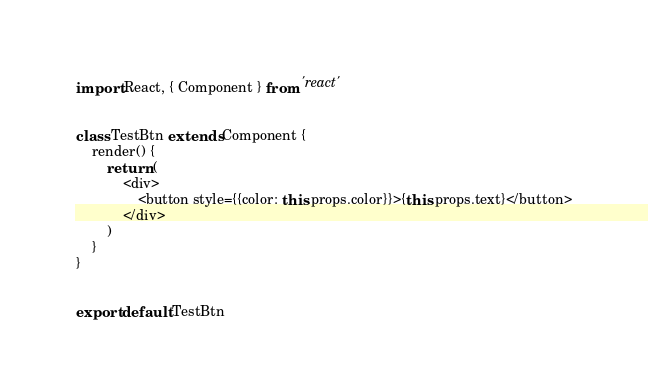<code> <loc_0><loc_0><loc_500><loc_500><_JavaScript_>import React, { Component } from 'react'


class TestBtn extends Component {
    render() {
        return (
            <div>
                <button style={{color: this.props.color}}>{this.props.text}</button>
            </div>
        )
    }
}


export default TestBtn</code> 